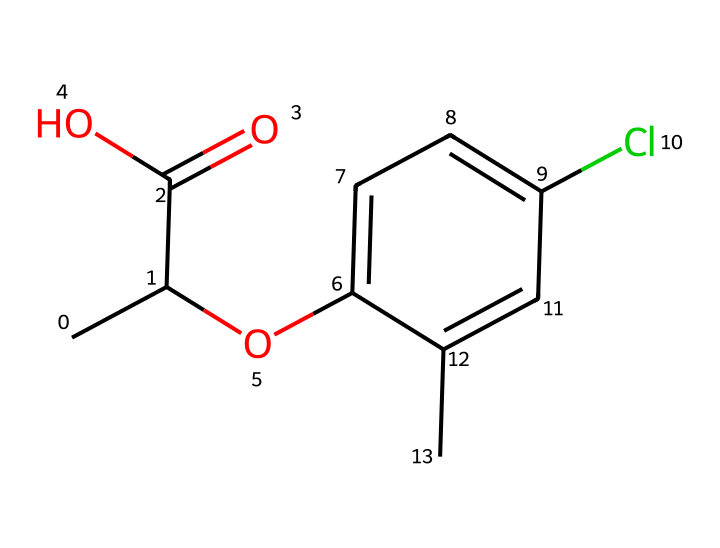What is the molecular formula of mecoprop? To determine the molecular formula, we analyze the SMILES string. Counting the atoms represented in the structure gives us 10 carbons, 11 hydrogens, 2 oxygens, and 1 chlorine. Thus, the molecular formula is C10H11ClO2.
Answer: C10H11ClO2 How many rings are present in the structure of mecoprop? The chemical structure presented does not have any rings present; the benzene ring is technically a cyclic structure but doesn't count as a different ring given its common presence in such compounds. Thus, the total count is 1 ring.
Answer: 1 ring What functional groups are present in mecoprop? Analyzing the structure shows the presence of a carboxylic acid group (due to the -COOH part), an ether (from the -O- linkage), and an aryl group from the aromatic ring. These indicate the presence of multiple functional groups.
Answer: carboxylic acid, ether, aryl Is mecoprop a selective or non-selective herbicide? Mecoprop is considered a selective herbicide, primarily targeting broadleaf weeds while leaving grasses unharmed due to its specific interaction with certain growth pathways.
Answer: selective What atom in mecoprop plays a critical role in its herbicide activity? The presence of the chlorine atom in mecoprop contributes to its activity due to its electron-withdrawing properties, which enhance the herbicide's effectiveness in disrupting plant growth processes.
Answer: chlorine What type of chemical is mecoprop? Mecoprop is categorized as a phenoxy herbicide, as it is derived from phenoxyacetic acid, which is characteristic of compounds designed to control specific plant growth.
Answer: phenoxy herbicide 